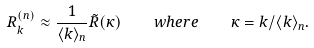<formula> <loc_0><loc_0><loc_500><loc_500>R _ { k } ^ { ( n ) } \approx \frac { 1 } { \langle k \rangle _ { n } } \tilde { R } ( \kappa ) \quad w h e r e \quad \kappa = k / \langle k \rangle _ { n } .</formula> 